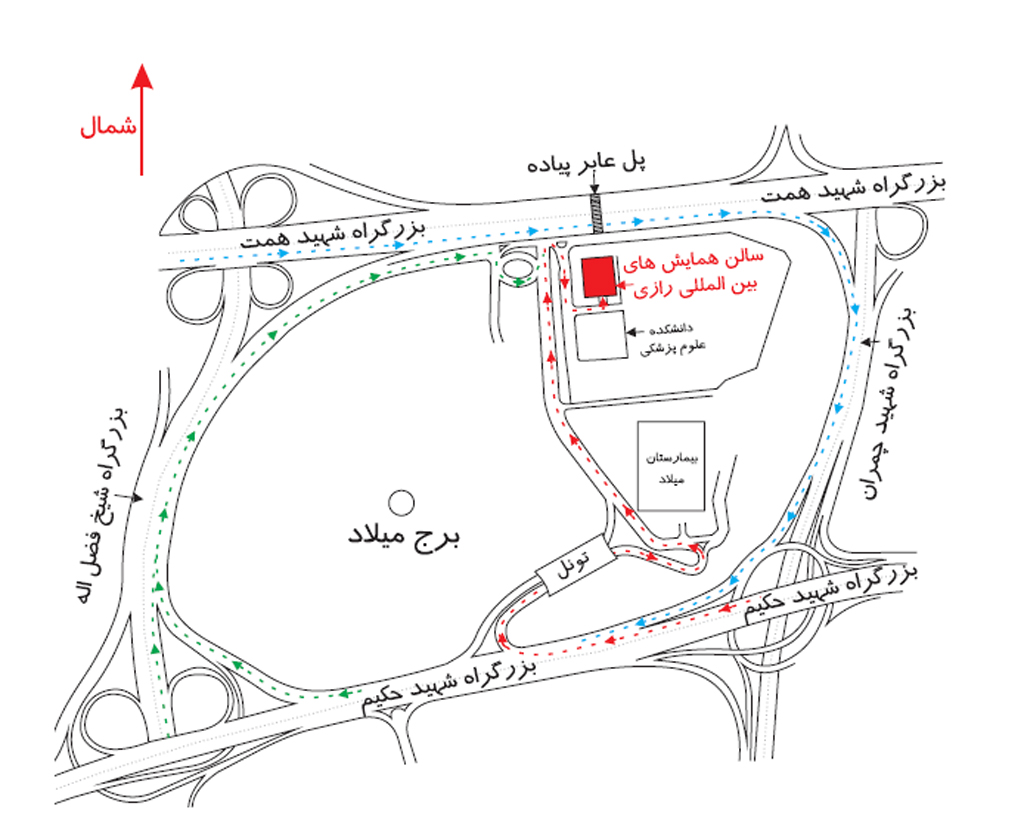من در برج میلاد هستم ، میخواهم بروم به سالن همایش های بین المللی رازی برای رفتن از برج میلاد به سالن همایش‌های بین‌المللی رازی، شما باید ابتدا از برج میلاد که در سمت راست بالای نقشه قرار دارد خارج شوید. سپس به سمت راست بپیچید و وارد بزرگراه شوید. بعد از آن باید از اولین خروجی سمت راست استفاده کنید تا به محوطه‌ای برسید که سالن همایش‌ها در آن قرار دارد. پس از خروج از بزرگراه، در محوطه‌ای که وارد شده‌اید باید به سمت چپ بپیچید و به سمت ساختمان سالن همایش‌های بین‌المللی رازی حرکت کنید که در وسط نقشه و کمی به سمت پایین قرار دارد. ساختمان رازی مستطیل شکل است و در وسط محوطه قرار گرفته است. من در برج میلاد هستم ، میخواهم بروم به سالن همایش های بین المللی رازی ، میتوانی مسیر را برای من مشخص کنی ؟ برای رفتن از برج میلاد به سالن همایش‌های بین‌المللی رازی، شما باید از مسیرهای مشخص‌شده در نقشه پیروی کنید. اگر در برج میلاد هستید، ابتدا باید به سمت جنوب بروید و به سمت بزرگراه حکیم حرکت کنید. پس از آن، به سمت شرق در بزرگراه حکیم حرکت کرده و از خروجی مشخص‌شده در نقشه که به سمت سالن همایش‌های رازی می‌رود، خارج شوید. مسیر شما در نقشه با خط قرمز مشخص شده است. بنابراین، پس از خروج از بزرگراه، به سمت شمال شرقی حرکت کنید تا به مقصد برسید. 